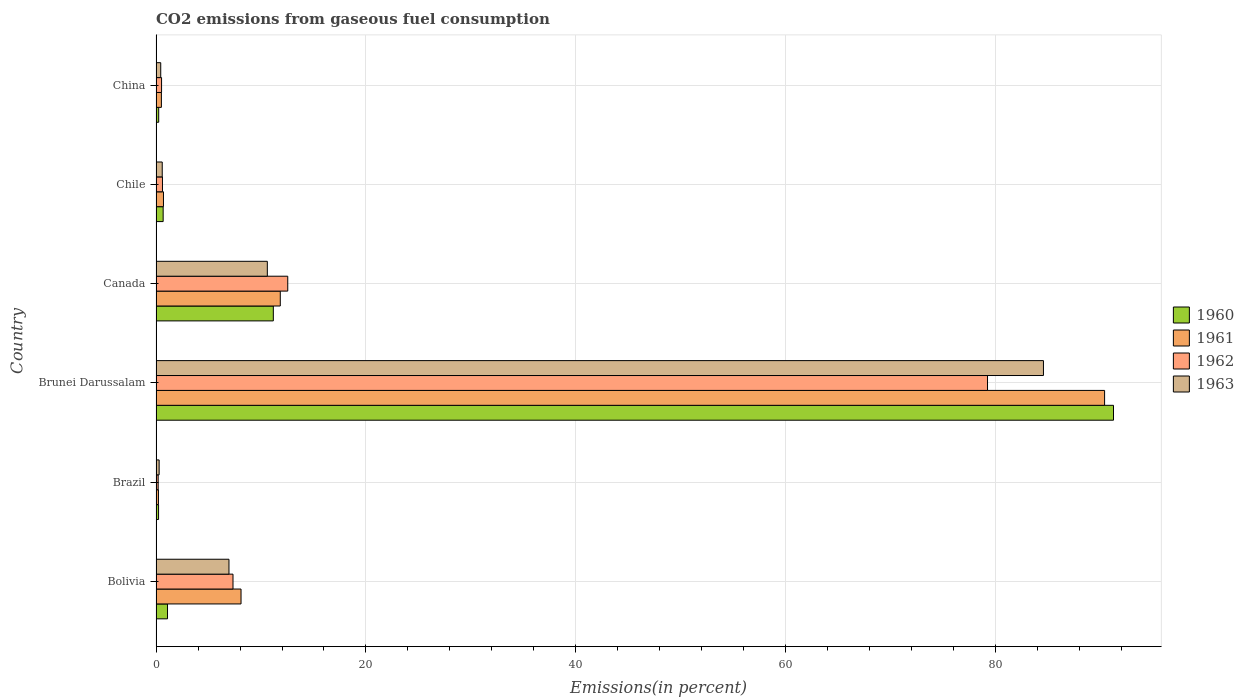How many groups of bars are there?
Ensure brevity in your answer.  6. How many bars are there on the 1st tick from the bottom?
Provide a succinct answer. 4. What is the total CO2 emitted in 1962 in Canada?
Your answer should be very brief. 12.55. Across all countries, what is the maximum total CO2 emitted in 1960?
Offer a very short reply. 91.21. Across all countries, what is the minimum total CO2 emitted in 1963?
Provide a short and direct response. 0.3. In which country was the total CO2 emitted in 1962 maximum?
Your answer should be compact. Brunei Darussalam. What is the total total CO2 emitted in 1960 in the graph?
Offer a very short reply. 104.66. What is the difference between the total CO2 emitted in 1961 in Brunei Darussalam and that in Chile?
Offer a very short reply. 89.65. What is the difference between the total CO2 emitted in 1962 in Brunei Darussalam and the total CO2 emitted in 1960 in Brazil?
Your response must be concise. 78.97. What is the average total CO2 emitted in 1963 per country?
Offer a very short reply. 17.24. What is the difference between the total CO2 emitted in 1963 and total CO2 emitted in 1962 in Chile?
Your answer should be very brief. -0.02. In how many countries, is the total CO2 emitted in 1960 greater than 60 %?
Ensure brevity in your answer.  1. What is the ratio of the total CO2 emitted in 1962 in Bolivia to that in China?
Offer a very short reply. 13.89. What is the difference between the highest and the second highest total CO2 emitted in 1961?
Offer a very short reply. 78.52. What is the difference between the highest and the lowest total CO2 emitted in 1960?
Provide a succinct answer. 90.97. Is it the case that in every country, the sum of the total CO2 emitted in 1962 and total CO2 emitted in 1961 is greater than the sum of total CO2 emitted in 1963 and total CO2 emitted in 1960?
Offer a terse response. No. What does the 2nd bar from the top in Canada represents?
Your answer should be compact. 1962. Is it the case that in every country, the sum of the total CO2 emitted in 1960 and total CO2 emitted in 1962 is greater than the total CO2 emitted in 1961?
Provide a succinct answer. Yes. How many bars are there?
Keep it short and to the point. 24. Are all the bars in the graph horizontal?
Give a very brief answer. Yes. How many countries are there in the graph?
Make the answer very short. 6. What is the difference between two consecutive major ticks on the X-axis?
Your response must be concise. 20. How are the legend labels stacked?
Give a very brief answer. Vertical. What is the title of the graph?
Ensure brevity in your answer.  CO2 emissions from gaseous fuel consumption. Does "1960" appear as one of the legend labels in the graph?
Your response must be concise. Yes. What is the label or title of the X-axis?
Keep it short and to the point. Emissions(in percent). What is the label or title of the Y-axis?
Your answer should be compact. Country. What is the Emissions(in percent) of 1960 in Bolivia?
Keep it short and to the point. 1.09. What is the Emissions(in percent) of 1961 in Bolivia?
Provide a succinct answer. 8.1. What is the Emissions(in percent) in 1962 in Bolivia?
Keep it short and to the point. 7.33. What is the Emissions(in percent) in 1963 in Bolivia?
Give a very brief answer. 6.95. What is the Emissions(in percent) of 1960 in Brazil?
Offer a very short reply. 0.24. What is the Emissions(in percent) in 1961 in Brazil?
Give a very brief answer. 0.23. What is the Emissions(in percent) in 1962 in Brazil?
Provide a short and direct response. 0.2. What is the Emissions(in percent) of 1963 in Brazil?
Your answer should be compact. 0.3. What is the Emissions(in percent) of 1960 in Brunei Darussalam?
Make the answer very short. 91.21. What is the Emissions(in percent) of 1961 in Brunei Darussalam?
Make the answer very short. 90.36. What is the Emissions(in percent) of 1962 in Brunei Darussalam?
Make the answer very short. 79.21. What is the Emissions(in percent) of 1963 in Brunei Darussalam?
Provide a succinct answer. 84.54. What is the Emissions(in percent) of 1960 in Canada?
Offer a terse response. 11.17. What is the Emissions(in percent) of 1961 in Canada?
Make the answer very short. 11.84. What is the Emissions(in percent) of 1962 in Canada?
Offer a very short reply. 12.55. What is the Emissions(in percent) in 1963 in Canada?
Offer a very short reply. 10.6. What is the Emissions(in percent) in 1960 in Chile?
Your answer should be very brief. 0.68. What is the Emissions(in percent) of 1961 in Chile?
Your answer should be compact. 0.71. What is the Emissions(in percent) in 1962 in Chile?
Offer a very short reply. 0.61. What is the Emissions(in percent) of 1963 in Chile?
Make the answer very short. 0.59. What is the Emissions(in percent) of 1960 in China?
Give a very brief answer. 0.26. What is the Emissions(in percent) of 1961 in China?
Your answer should be very brief. 0.51. What is the Emissions(in percent) of 1962 in China?
Your response must be concise. 0.53. What is the Emissions(in percent) in 1963 in China?
Give a very brief answer. 0.45. Across all countries, what is the maximum Emissions(in percent) of 1960?
Your response must be concise. 91.21. Across all countries, what is the maximum Emissions(in percent) of 1961?
Make the answer very short. 90.36. Across all countries, what is the maximum Emissions(in percent) in 1962?
Provide a short and direct response. 79.21. Across all countries, what is the maximum Emissions(in percent) in 1963?
Keep it short and to the point. 84.54. Across all countries, what is the minimum Emissions(in percent) in 1960?
Offer a very short reply. 0.24. Across all countries, what is the minimum Emissions(in percent) of 1961?
Offer a terse response. 0.23. Across all countries, what is the minimum Emissions(in percent) in 1962?
Your answer should be very brief. 0.2. Across all countries, what is the minimum Emissions(in percent) of 1963?
Offer a very short reply. 0.3. What is the total Emissions(in percent) in 1960 in the graph?
Your answer should be very brief. 104.66. What is the total Emissions(in percent) of 1961 in the graph?
Keep it short and to the point. 111.75. What is the total Emissions(in percent) in 1962 in the graph?
Make the answer very short. 100.44. What is the total Emissions(in percent) of 1963 in the graph?
Your response must be concise. 103.42. What is the difference between the Emissions(in percent) of 1960 in Bolivia and that in Brazil?
Your response must be concise. 0.85. What is the difference between the Emissions(in percent) in 1961 in Bolivia and that in Brazil?
Ensure brevity in your answer.  7.87. What is the difference between the Emissions(in percent) in 1962 in Bolivia and that in Brazil?
Your answer should be compact. 7.13. What is the difference between the Emissions(in percent) of 1963 in Bolivia and that in Brazil?
Make the answer very short. 6.65. What is the difference between the Emissions(in percent) of 1960 in Bolivia and that in Brunei Darussalam?
Offer a terse response. -90.11. What is the difference between the Emissions(in percent) in 1961 in Bolivia and that in Brunei Darussalam?
Your response must be concise. -82.26. What is the difference between the Emissions(in percent) of 1962 in Bolivia and that in Brunei Darussalam?
Your answer should be very brief. -71.87. What is the difference between the Emissions(in percent) of 1963 in Bolivia and that in Brunei Darussalam?
Offer a terse response. -77.59. What is the difference between the Emissions(in percent) in 1960 in Bolivia and that in Canada?
Offer a terse response. -10.08. What is the difference between the Emissions(in percent) in 1961 in Bolivia and that in Canada?
Offer a very short reply. -3.74. What is the difference between the Emissions(in percent) of 1962 in Bolivia and that in Canada?
Give a very brief answer. -5.22. What is the difference between the Emissions(in percent) in 1963 in Bolivia and that in Canada?
Ensure brevity in your answer.  -3.65. What is the difference between the Emissions(in percent) in 1960 in Bolivia and that in Chile?
Make the answer very short. 0.42. What is the difference between the Emissions(in percent) of 1961 in Bolivia and that in Chile?
Provide a short and direct response. 7.39. What is the difference between the Emissions(in percent) in 1962 in Bolivia and that in Chile?
Offer a terse response. 6.72. What is the difference between the Emissions(in percent) in 1963 in Bolivia and that in Chile?
Your answer should be very brief. 6.36. What is the difference between the Emissions(in percent) in 1960 in Bolivia and that in China?
Provide a succinct answer. 0.84. What is the difference between the Emissions(in percent) of 1961 in Bolivia and that in China?
Ensure brevity in your answer.  7.59. What is the difference between the Emissions(in percent) of 1962 in Bolivia and that in China?
Your answer should be compact. 6.81. What is the difference between the Emissions(in percent) in 1963 in Bolivia and that in China?
Your answer should be compact. 6.5. What is the difference between the Emissions(in percent) of 1960 in Brazil and that in Brunei Darussalam?
Offer a terse response. -90.97. What is the difference between the Emissions(in percent) in 1961 in Brazil and that in Brunei Darussalam?
Your answer should be compact. -90.13. What is the difference between the Emissions(in percent) in 1962 in Brazil and that in Brunei Darussalam?
Provide a succinct answer. -79. What is the difference between the Emissions(in percent) of 1963 in Brazil and that in Brunei Darussalam?
Offer a terse response. -84.24. What is the difference between the Emissions(in percent) in 1960 in Brazil and that in Canada?
Give a very brief answer. -10.93. What is the difference between the Emissions(in percent) of 1961 in Brazil and that in Canada?
Your answer should be compact. -11.61. What is the difference between the Emissions(in percent) of 1962 in Brazil and that in Canada?
Offer a terse response. -12.34. What is the difference between the Emissions(in percent) of 1963 in Brazil and that in Canada?
Provide a short and direct response. -10.31. What is the difference between the Emissions(in percent) in 1960 in Brazil and that in Chile?
Your response must be concise. -0.44. What is the difference between the Emissions(in percent) in 1961 in Brazil and that in Chile?
Offer a terse response. -0.48. What is the difference between the Emissions(in percent) of 1962 in Brazil and that in Chile?
Your answer should be compact. -0.41. What is the difference between the Emissions(in percent) of 1963 in Brazil and that in Chile?
Keep it short and to the point. -0.29. What is the difference between the Emissions(in percent) in 1960 in Brazil and that in China?
Offer a terse response. -0.01. What is the difference between the Emissions(in percent) of 1961 in Brazil and that in China?
Offer a very short reply. -0.28. What is the difference between the Emissions(in percent) of 1962 in Brazil and that in China?
Keep it short and to the point. -0.32. What is the difference between the Emissions(in percent) in 1963 in Brazil and that in China?
Keep it short and to the point. -0.15. What is the difference between the Emissions(in percent) of 1960 in Brunei Darussalam and that in Canada?
Your response must be concise. 80.03. What is the difference between the Emissions(in percent) of 1961 in Brunei Darussalam and that in Canada?
Give a very brief answer. 78.52. What is the difference between the Emissions(in percent) in 1962 in Brunei Darussalam and that in Canada?
Give a very brief answer. 66.66. What is the difference between the Emissions(in percent) of 1963 in Brunei Darussalam and that in Canada?
Provide a succinct answer. 73.93. What is the difference between the Emissions(in percent) of 1960 in Brunei Darussalam and that in Chile?
Ensure brevity in your answer.  90.53. What is the difference between the Emissions(in percent) in 1961 in Brunei Darussalam and that in Chile?
Provide a succinct answer. 89.65. What is the difference between the Emissions(in percent) in 1962 in Brunei Darussalam and that in Chile?
Give a very brief answer. 78.59. What is the difference between the Emissions(in percent) in 1963 in Brunei Darussalam and that in Chile?
Give a very brief answer. 83.94. What is the difference between the Emissions(in percent) of 1960 in Brunei Darussalam and that in China?
Keep it short and to the point. 90.95. What is the difference between the Emissions(in percent) in 1961 in Brunei Darussalam and that in China?
Provide a succinct answer. 89.85. What is the difference between the Emissions(in percent) of 1962 in Brunei Darussalam and that in China?
Your answer should be compact. 78.68. What is the difference between the Emissions(in percent) in 1963 in Brunei Darussalam and that in China?
Ensure brevity in your answer.  84.09. What is the difference between the Emissions(in percent) of 1960 in Canada and that in Chile?
Your answer should be compact. 10.49. What is the difference between the Emissions(in percent) of 1961 in Canada and that in Chile?
Make the answer very short. 11.13. What is the difference between the Emissions(in percent) in 1962 in Canada and that in Chile?
Make the answer very short. 11.93. What is the difference between the Emissions(in percent) in 1963 in Canada and that in Chile?
Keep it short and to the point. 10.01. What is the difference between the Emissions(in percent) of 1960 in Canada and that in China?
Provide a short and direct response. 10.92. What is the difference between the Emissions(in percent) in 1961 in Canada and that in China?
Provide a succinct answer. 11.33. What is the difference between the Emissions(in percent) of 1962 in Canada and that in China?
Make the answer very short. 12.02. What is the difference between the Emissions(in percent) of 1963 in Canada and that in China?
Offer a terse response. 10.15. What is the difference between the Emissions(in percent) in 1960 in Chile and that in China?
Offer a terse response. 0.42. What is the difference between the Emissions(in percent) of 1961 in Chile and that in China?
Ensure brevity in your answer.  0.2. What is the difference between the Emissions(in percent) of 1962 in Chile and that in China?
Keep it short and to the point. 0.09. What is the difference between the Emissions(in percent) of 1963 in Chile and that in China?
Your answer should be compact. 0.14. What is the difference between the Emissions(in percent) of 1960 in Bolivia and the Emissions(in percent) of 1961 in Brazil?
Your answer should be very brief. 0.86. What is the difference between the Emissions(in percent) of 1960 in Bolivia and the Emissions(in percent) of 1962 in Brazil?
Provide a short and direct response. 0.89. What is the difference between the Emissions(in percent) of 1960 in Bolivia and the Emissions(in percent) of 1963 in Brazil?
Your response must be concise. 0.8. What is the difference between the Emissions(in percent) of 1961 in Bolivia and the Emissions(in percent) of 1962 in Brazil?
Ensure brevity in your answer.  7.89. What is the difference between the Emissions(in percent) in 1961 in Bolivia and the Emissions(in percent) in 1963 in Brazil?
Provide a short and direct response. 7.8. What is the difference between the Emissions(in percent) in 1962 in Bolivia and the Emissions(in percent) in 1963 in Brazil?
Give a very brief answer. 7.04. What is the difference between the Emissions(in percent) of 1960 in Bolivia and the Emissions(in percent) of 1961 in Brunei Darussalam?
Ensure brevity in your answer.  -89.27. What is the difference between the Emissions(in percent) in 1960 in Bolivia and the Emissions(in percent) in 1962 in Brunei Darussalam?
Make the answer very short. -78.11. What is the difference between the Emissions(in percent) of 1960 in Bolivia and the Emissions(in percent) of 1963 in Brunei Darussalam?
Give a very brief answer. -83.44. What is the difference between the Emissions(in percent) of 1961 in Bolivia and the Emissions(in percent) of 1962 in Brunei Darussalam?
Your answer should be very brief. -71.11. What is the difference between the Emissions(in percent) of 1961 in Bolivia and the Emissions(in percent) of 1963 in Brunei Darussalam?
Keep it short and to the point. -76.44. What is the difference between the Emissions(in percent) of 1962 in Bolivia and the Emissions(in percent) of 1963 in Brunei Darussalam?
Provide a short and direct response. -77.2. What is the difference between the Emissions(in percent) of 1960 in Bolivia and the Emissions(in percent) of 1961 in Canada?
Keep it short and to the point. -10.74. What is the difference between the Emissions(in percent) of 1960 in Bolivia and the Emissions(in percent) of 1962 in Canada?
Provide a succinct answer. -11.45. What is the difference between the Emissions(in percent) of 1960 in Bolivia and the Emissions(in percent) of 1963 in Canada?
Your response must be concise. -9.51. What is the difference between the Emissions(in percent) of 1961 in Bolivia and the Emissions(in percent) of 1962 in Canada?
Ensure brevity in your answer.  -4.45. What is the difference between the Emissions(in percent) of 1961 in Bolivia and the Emissions(in percent) of 1963 in Canada?
Make the answer very short. -2.5. What is the difference between the Emissions(in percent) of 1962 in Bolivia and the Emissions(in percent) of 1963 in Canada?
Provide a short and direct response. -3.27. What is the difference between the Emissions(in percent) in 1960 in Bolivia and the Emissions(in percent) in 1961 in Chile?
Your answer should be compact. 0.39. What is the difference between the Emissions(in percent) in 1960 in Bolivia and the Emissions(in percent) in 1962 in Chile?
Offer a very short reply. 0.48. What is the difference between the Emissions(in percent) in 1960 in Bolivia and the Emissions(in percent) in 1963 in Chile?
Provide a succinct answer. 0.5. What is the difference between the Emissions(in percent) of 1961 in Bolivia and the Emissions(in percent) of 1962 in Chile?
Your answer should be compact. 7.48. What is the difference between the Emissions(in percent) of 1961 in Bolivia and the Emissions(in percent) of 1963 in Chile?
Keep it short and to the point. 7.51. What is the difference between the Emissions(in percent) in 1962 in Bolivia and the Emissions(in percent) in 1963 in Chile?
Your answer should be compact. 6.74. What is the difference between the Emissions(in percent) of 1960 in Bolivia and the Emissions(in percent) of 1961 in China?
Keep it short and to the point. 0.58. What is the difference between the Emissions(in percent) of 1960 in Bolivia and the Emissions(in percent) of 1962 in China?
Make the answer very short. 0.57. What is the difference between the Emissions(in percent) of 1960 in Bolivia and the Emissions(in percent) of 1963 in China?
Provide a succinct answer. 0.65. What is the difference between the Emissions(in percent) of 1961 in Bolivia and the Emissions(in percent) of 1962 in China?
Your answer should be compact. 7.57. What is the difference between the Emissions(in percent) in 1961 in Bolivia and the Emissions(in percent) in 1963 in China?
Keep it short and to the point. 7.65. What is the difference between the Emissions(in percent) in 1962 in Bolivia and the Emissions(in percent) in 1963 in China?
Your response must be concise. 6.88. What is the difference between the Emissions(in percent) in 1960 in Brazil and the Emissions(in percent) in 1961 in Brunei Darussalam?
Make the answer very short. -90.12. What is the difference between the Emissions(in percent) of 1960 in Brazil and the Emissions(in percent) of 1962 in Brunei Darussalam?
Your answer should be compact. -78.97. What is the difference between the Emissions(in percent) of 1960 in Brazil and the Emissions(in percent) of 1963 in Brunei Darussalam?
Your answer should be very brief. -84.29. What is the difference between the Emissions(in percent) of 1961 in Brazil and the Emissions(in percent) of 1962 in Brunei Darussalam?
Give a very brief answer. -78.98. What is the difference between the Emissions(in percent) in 1961 in Brazil and the Emissions(in percent) in 1963 in Brunei Darussalam?
Provide a succinct answer. -84.31. What is the difference between the Emissions(in percent) in 1962 in Brazil and the Emissions(in percent) in 1963 in Brunei Darussalam?
Offer a terse response. -84.33. What is the difference between the Emissions(in percent) of 1960 in Brazil and the Emissions(in percent) of 1961 in Canada?
Offer a very short reply. -11.59. What is the difference between the Emissions(in percent) in 1960 in Brazil and the Emissions(in percent) in 1962 in Canada?
Keep it short and to the point. -12.31. What is the difference between the Emissions(in percent) in 1960 in Brazil and the Emissions(in percent) in 1963 in Canada?
Make the answer very short. -10.36. What is the difference between the Emissions(in percent) of 1961 in Brazil and the Emissions(in percent) of 1962 in Canada?
Give a very brief answer. -12.32. What is the difference between the Emissions(in percent) in 1961 in Brazil and the Emissions(in percent) in 1963 in Canada?
Offer a very short reply. -10.37. What is the difference between the Emissions(in percent) in 1962 in Brazil and the Emissions(in percent) in 1963 in Canada?
Provide a succinct answer. -10.4. What is the difference between the Emissions(in percent) of 1960 in Brazil and the Emissions(in percent) of 1961 in Chile?
Provide a succinct answer. -0.47. What is the difference between the Emissions(in percent) in 1960 in Brazil and the Emissions(in percent) in 1962 in Chile?
Provide a short and direct response. -0.37. What is the difference between the Emissions(in percent) of 1960 in Brazil and the Emissions(in percent) of 1963 in Chile?
Your response must be concise. -0.35. What is the difference between the Emissions(in percent) of 1961 in Brazil and the Emissions(in percent) of 1962 in Chile?
Make the answer very short. -0.38. What is the difference between the Emissions(in percent) in 1961 in Brazil and the Emissions(in percent) in 1963 in Chile?
Keep it short and to the point. -0.36. What is the difference between the Emissions(in percent) in 1962 in Brazil and the Emissions(in percent) in 1963 in Chile?
Provide a succinct answer. -0.39. What is the difference between the Emissions(in percent) in 1960 in Brazil and the Emissions(in percent) in 1961 in China?
Provide a succinct answer. -0.27. What is the difference between the Emissions(in percent) of 1960 in Brazil and the Emissions(in percent) of 1962 in China?
Your response must be concise. -0.29. What is the difference between the Emissions(in percent) in 1960 in Brazil and the Emissions(in percent) in 1963 in China?
Offer a terse response. -0.21. What is the difference between the Emissions(in percent) in 1961 in Brazil and the Emissions(in percent) in 1962 in China?
Offer a very short reply. -0.3. What is the difference between the Emissions(in percent) in 1961 in Brazil and the Emissions(in percent) in 1963 in China?
Provide a succinct answer. -0.22. What is the difference between the Emissions(in percent) of 1962 in Brazil and the Emissions(in percent) of 1963 in China?
Provide a succinct answer. -0.24. What is the difference between the Emissions(in percent) of 1960 in Brunei Darussalam and the Emissions(in percent) of 1961 in Canada?
Your answer should be very brief. 79.37. What is the difference between the Emissions(in percent) in 1960 in Brunei Darussalam and the Emissions(in percent) in 1962 in Canada?
Make the answer very short. 78.66. What is the difference between the Emissions(in percent) in 1960 in Brunei Darussalam and the Emissions(in percent) in 1963 in Canada?
Give a very brief answer. 80.61. What is the difference between the Emissions(in percent) in 1961 in Brunei Darussalam and the Emissions(in percent) in 1962 in Canada?
Your response must be concise. 77.81. What is the difference between the Emissions(in percent) in 1961 in Brunei Darussalam and the Emissions(in percent) in 1963 in Canada?
Make the answer very short. 79.76. What is the difference between the Emissions(in percent) in 1962 in Brunei Darussalam and the Emissions(in percent) in 1963 in Canada?
Your response must be concise. 68.61. What is the difference between the Emissions(in percent) of 1960 in Brunei Darussalam and the Emissions(in percent) of 1961 in Chile?
Your answer should be very brief. 90.5. What is the difference between the Emissions(in percent) in 1960 in Brunei Darussalam and the Emissions(in percent) in 1962 in Chile?
Your response must be concise. 90.59. What is the difference between the Emissions(in percent) of 1960 in Brunei Darussalam and the Emissions(in percent) of 1963 in Chile?
Give a very brief answer. 90.62. What is the difference between the Emissions(in percent) of 1961 in Brunei Darussalam and the Emissions(in percent) of 1962 in Chile?
Make the answer very short. 89.75. What is the difference between the Emissions(in percent) in 1961 in Brunei Darussalam and the Emissions(in percent) in 1963 in Chile?
Ensure brevity in your answer.  89.77. What is the difference between the Emissions(in percent) of 1962 in Brunei Darussalam and the Emissions(in percent) of 1963 in Chile?
Give a very brief answer. 78.62. What is the difference between the Emissions(in percent) in 1960 in Brunei Darussalam and the Emissions(in percent) in 1961 in China?
Give a very brief answer. 90.7. What is the difference between the Emissions(in percent) in 1960 in Brunei Darussalam and the Emissions(in percent) in 1962 in China?
Make the answer very short. 90.68. What is the difference between the Emissions(in percent) in 1960 in Brunei Darussalam and the Emissions(in percent) in 1963 in China?
Give a very brief answer. 90.76. What is the difference between the Emissions(in percent) of 1961 in Brunei Darussalam and the Emissions(in percent) of 1962 in China?
Make the answer very short. 89.83. What is the difference between the Emissions(in percent) in 1961 in Brunei Darussalam and the Emissions(in percent) in 1963 in China?
Provide a short and direct response. 89.91. What is the difference between the Emissions(in percent) in 1962 in Brunei Darussalam and the Emissions(in percent) in 1963 in China?
Your answer should be compact. 78.76. What is the difference between the Emissions(in percent) of 1960 in Canada and the Emissions(in percent) of 1961 in Chile?
Your response must be concise. 10.46. What is the difference between the Emissions(in percent) in 1960 in Canada and the Emissions(in percent) in 1962 in Chile?
Provide a short and direct response. 10.56. What is the difference between the Emissions(in percent) in 1960 in Canada and the Emissions(in percent) in 1963 in Chile?
Ensure brevity in your answer.  10.58. What is the difference between the Emissions(in percent) of 1961 in Canada and the Emissions(in percent) of 1962 in Chile?
Keep it short and to the point. 11.22. What is the difference between the Emissions(in percent) in 1961 in Canada and the Emissions(in percent) in 1963 in Chile?
Give a very brief answer. 11.25. What is the difference between the Emissions(in percent) of 1962 in Canada and the Emissions(in percent) of 1963 in Chile?
Your answer should be very brief. 11.96. What is the difference between the Emissions(in percent) in 1960 in Canada and the Emissions(in percent) in 1961 in China?
Offer a terse response. 10.66. What is the difference between the Emissions(in percent) in 1960 in Canada and the Emissions(in percent) in 1962 in China?
Ensure brevity in your answer.  10.65. What is the difference between the Emissions(in percent) of 1960 in Canada and the Emissions(in percent) of 1963 in China?
Keep it short and to the point. 10.73. What is the difference between the Emissions(in percent) of 1961 in Canada and the Emissions(in percent) of 1962 in China?
Your answer should be very brief. 11.31. What is the difference between the Emissions(in percent) of 1961 in Canada and the Emissions(in percent) of 1963 in China?
Give a very brief answer. 11.39. What is the difference between the Emissions(in percent) of 1962 in Canada and the Emissions(in percent) of 1963 in China?
Your answer should be compact. 12.1. What is the difference between the Emissions(in percent) in 1960 in Chile and the Emissions(in percent) in 1961 in China?
Keep it short and to the point. 0.17. What is the difference between the Emissions(in percent) in 1960 in Chile and the Emissions(in percent) in 1962 in China?
Provide a succinct answer. 0.15. What is the difference between the Emissions(in percent) in 1960 in Chile and the Emissions(in percent) in 1963 in China?
Provide a short and direct response. 0.23. What is the difference between the Emissions(in percent) of 1961 in Chile and the Emissions(in percent) of 1962 in China?
Ensure brevity in your answer.  0.18. What is the difference between the Emissions(in percent) of 1961 in Chile and the Emissions(in percent) of 1963 in China?
Make the answer very short. 0.26. What is the difference between the Emissions(in percent) in 1962 in Chile and the Emissions(in percent) in 1963 in China?
Offer a terse response. 0.17. What is the average Emissions(in percent) of 1960 per country?
Your answer should be compact. 17.44. What is the average Emissions(in percent) of 1961 per country?
Your answer should be very brief. 18.62. What is the average Emissions(in percent) of 1962 per country?
Ensure brevity in your answer.  16.74. What is the average Emissions(in percent) in 1963 per country?
Offer a terse response. 17.24. What is the difference between the Emissions(in percent) of 1960 and Emissions(in percent) of 1961 in Bolivia?
Your answer should be very brief. -7. What is the difference between the Emissions(in percent) in 1960 and Emissions(in percent) in 1962 in Bolivia?
Provide a short and direct response. -6.24. What is the difference between the Emissions(in percent) of 1960 and Emissions(in percent) of 1963 in Bolivia?
Your answer should be very brief. -5.85. What is the difference between the Emissions(in percent) in 1961 and Emissions(in percent) in 1962 in Bolivia?
Your answer should be very brief. 0.77. What is the difference between the Emissions(in percent) in 1961 and Emissions(in percent) in 1963 in Bolivia?
Your answer should be compact. 1.15. What is the difference between the Emissions(in percent) in 1962 and Emissions(in percent) in 1963 in Bolivia?
Keep it short and to the point. 0.38. What is the difference between the Emissions(in percent) of 1960 and Emissions(in percent) of 1961 in Brazil?
Give a very brief answer. 0.01. What is the difference between the Emissions(in percent) in 1960 and Emissions(in percent) in 1962 in Brazil?
Ensure brevity in your answer.  0.04. What is the difference between the Emissions(in percent) of 1960 and Emissions(in percent) of 1963 in Brazil?
Make the answer very short. -0.05. What is the difference between the Emissions(in percent) in 1961 and Emissions(in percent) in 1962 in Brazil?
Give a very brief answer. 0.03. What is the difference between the Emissions(in percent) of 1961 and Emissions(in percent) of 1963 in Brazil?
Make the answer very short. -0.07. What is the difference between the Emissions(in percent) in 1962 and Emissions(in percent) in 1963 in Brazil?
Keep it short and to the point. -0.09. What is the difference between the Emissions(in percent) of 1960 and Emissions(in percent) of 1961 in Brunei Darussalam?
Keep it short and to the point. 0.85. What is the difference between the Emissions(in percent) in 1960 and Emissions(in percent) in 1962 in Brunei Darussalam?
Ensure brevity in your answer.  12. What is the difference between the Emissions(in percent) in 1960 and Emissions(in percent) in 1963 in Brunei Darussalam?
Offer a terse response. 6.67. What is the difference between the Emissions(in percent) in 1961 and Emissions(in percent) in 1962 in Brunei Darussalam?
Provide a short and direct response. 11.15. What is the difference between the Emissions(in percent) in 1961 and Emissions(in percent) in 1963 in Brunei Darussalam?
Make the answer very short. 5.83. What is the difference between the Emissions(in percent) of 1962 and Emissions(in percent) of 1963 in Brunei Darussalam?
Keep it short and to the point. -5.33. What is the difference between the Emissions(in percent) in 1960 and Emissions(in percent) in 1961 in Canada?
Your response must be concise. -0.66. What is the difference between the Emissions(in percent) of 1960 and Emissions(in percent) of 1962 in Canada?
Give a very brief answer. -1.37. What is the difference between the Emissions(in percent) of 1960 and Emissions(in percent) of 1963 in Canada?
Give a very brief answer. 0.57. What is the difference between the Emissions(in percent) of 1961 and Emissions(in percent) of 1962 in Canada?
Keep it short and to the point. -0.71. What is the difference between the Emissions(in percent) in 1961 and Emissions(in percent) in 1963 in Canada?
Make the answer very short. 1.23. What is the difference between the Emissions(in percent) in 1962 and Emissions(in percent) in 1963 in Canada?
Your response must be concise. 1.95. What is the difference between the Emissions(in percent) of 1960 and Emissions(in percent) of 1961 in Chile?
Provide a short and direct response. -0.03. What is the difference between the Emissions(in percent) in 1960 and Emissions(in percent) in 1962 in Chile?
Your response must be concise. 0.07. What is the difference between the Emissions(in percent) in 1960 and Emissions(in percent) in 1963 in Chile?
Offer a terse response. 0.09. What is the difference between the Emissions(in percent) of 1961 and Emissions(in percent) of 1962 in Chile?
Give a very brief answer. 0.1. What is the difference between the Emissions(in percent) of 1961 and Emissions(in percent) of 1963 in Chile?
Provide a succinct answer. 0.12. What is the difference between the Emissions(in percent) of 1962 and Emissions(in percent) of 1963 in Chile?
Your answer should be compact. 0.02. What is the difference between the Emissions(in percent) of 1960 and Emissions(in percent) of 1961 in China?
Ensure brevity in your answer.  -0.26. What is the difference between the Emissions(in percent) of 1960 and Emissions(in percent) of 1962 in China?
Your response must be concise. -0.27. What is the difference between the Emissions(in percent) in 1960 and Emissions(in percent) in 1963 in China?
Ensure brevity in your answer.  -0.19. What is the difference between the Emissions(in percent) in 1961 and Emissions(in percent) in 1962 in China?
Offer a very short reply. -0.02. What is the difference between the Emissions(in percent) in 1961 and Emissions(in percent) in 1963 in China?
Provide a short and direct response. 0.06. What is the difference between the Emissions(in percent) in 1962 and Emissions(in percent) in 1963 in China?
Make the answer very short. 0.08. What is the ratio of the Emissions(in percent) of 1960 in Bolivia to that in Brazil?
Your answer should be very brief. 4.52. What is the ratio of the Emissions(in percent) in 1961 in Bolivia to that in Brazil?
Provide a short and direct response. 35.05. What is the ratio of the Emissions(in percent) in 1962 in Bolivia to that in Brazil?
Offer a very short reply. 35.79. What is the ratio of the Emissions(in percent) in 1963 in Bolivia to that in Brazil?
Your answer should be very brief. 23.42. What is the ratio of the Emissions(in percent) of 1960 in Bolivia to that in Brunei Darussalam?
Make the answer very short. 0.01. What is the ratio of the Emissions(in percent) of 1961 in Bolivia to that in Brunei Darussalam?
Your answer should be very brief. 0.09. What is the ratio of the Emissions(in percent) of 1962 in Bolivia to that in Brunei Darussalam?
Your answer should be compact. 0.09. What is the ratio of the Emissions(in percent) of 1963 in Bolivia to that in Brunei Darussalam?
Offer a terse response. 0.08. What is the ratio of the Emissions(in percent) of 1960 in Bolivia to that in Canada?
Offer a terse response. 0.1. What is the ratio of the Emissions(in percent) in 1961 in Bolivia to that in Canada?
Keep it short and to the point. 0.68. What is the ratio of the Emissions(in percent) of 1962 in Bolivia to that in Canada?
Give a very brief answer. 0.58. What is the ratio of the Emissions(in percent) of 1963 in Bolivia to that in Canada?
Your response must be concise. 0.66. What is the ratio of the Emissions(in percent) of 1960 in Bolivia to that in Chile?
Ensure brevity in your answer.  1.61. What is the ratio of the Emissions(in percent) of 1961 in Bolivia to that in Chile?
Your answer should be compact. 11.42. What is the ratio of the Emissions(in percent) of 1962 in Bolivia to that in Chile?
Provide a succinct answer. 11.95. What is the ratio of the Emissions(in percent) in 1963 in Bolivia to that in Chile?
Your answer should be very brief. 11.75. What is the ratio of the Emissions(in percent) in 1960 in Bolivia to that in China?
Keep it short and to the point. 4.29. What is the ratio of the Emissions(in percent) of 1961 in Bolivia to that in China?
Provide a succinct answer. 15.85. What is the ratio of the Emissions(in percent) of 1962 in Bolivia to that in China?
Your answer should be compact. 13.89. What is the ratio of the Emissions(in percent) of 1963 in Bolivia to that in China?
Offer a very short reply. 15.5. What is the ratio of the Emissions(in percent) in 1960 in Brazil to that in Brunei Darussalam?
Keep it short and to the point. 0. What is the ratio of the Emissions(in percent) of 1961 in Brazil to that in Brunei Darussalam?
Give a very brief answer. 0. What is the ratio of the Emissions(in percent) of 1962 in Brazil to that in Brunei Darussalam?
Your answer should be compact. 0. What is the ratio of the Emissions(in percent) of 1963 in Brazil to that in Brunei Darussalam?
Your answer should be compact. 0. What is the ratio of the Emissions(in percent) in 1960 in Brazil to that in Canada?
Make the answer very short. 0.02. What is the ratio of the Emissions(in percent) of 1961 in Brazil to that in Canada?
Provide a short and direct response. 0.02. What is the ratio of the Emissions(in percent) in 1962 in Brazil to that in Canada?
Your answer should be very brief. 0.02. What is the ratio of the Emissions(in percent) of 1963 in Brazil to that in Canada?
Your answer should be very brief. 0.03. What is the ratio of the Emissions(in percent) of 1960 in Brazil to that in Chile?
Your answer should be very brief. 0.36. What is the ratio of the Emissions(in percent) in 1961 in Brazil to that in Chile?
Your answer should be very brief. 0.33. What is the ratio of the Emissions(in percent) in 1962 in Brazil to that in Chile?
Give a very brief answer. 0.33. What is the ratio of the Emissions(in percent) in 1963 in Brazil to that in Chile?
Ensure brevity in your answer.  0.5. What is the ratio of the Emissions(in percent) in 1960 in Brazil to that in China?
Provide a succinct answer. 0.95. What is the ratio of the Emissions(in percent) in 1961 in Brazil to that in China?
Make the answer very short. 0.45. What is the ratio of the Emissions(in percent) of 1962 in Brazil to that in China?
Provide a succinct answer. 0.39. What is the ratio of the Emissions(in percent) of 1963 in Brazil to that in China?
Ensure brevity in your answer.  0.66. What is the ratio of the Emissions(in percent) of 1960 in Brunei Darussalam to that in Canada?
Offer a terse response. 8.16. What is the ratio of the Emissions(in percent) in 1961 in Brunei Darussalam to that in Canada?
Offer a very short reply. 7.63. What is the ratio of the Emissions(in percent) in 1962 in Brunei Darussalam to that in Canada?
Provide a succinct answer. 6.31. What is the ratio of the Emissions(in percent) of 1963 in Brunei Darussalam to that in Canada?
Provide a short and direct response. 7.97. What is the ratio of the Emissions(in percent) in 1960 in Brunei Darussalam to that in Chile?
Offer a terse response. 134.22. What is the ratio of the Emissions(in percent) of 1961 in Brunei Darussalam to that in Chile?
Your answer should be compact. 127.38. What is the ratio of the Emissions(in percent) in 1962 in Brunei Darussalam to that in Chile?
Offer a terse response. 129.02. What is the ratio of the Emissions(in percent) in 1963 in Brunei Darussalam to that in Chile?
Provide a succinct answer. 142.9. What is the ratio of the Emissions(in percent) of 1960 in Brunei Darussalam to that in China?
Your answer should be very brief. 356.97. What is the ratio of the Emissions(in percent) of 1961 in Brunei Darussalam to that in China?
Keep it short and to the point. 176.9. What is the ratio of the Emissions(in percent) in 1962 in Brunei Darussalam to that in China?
Keep it short and to the point. 150.03. What is the ratio of the Emissions(in percent) of 1963 in Brunei Darussalam to that in China?
Your answer should be very brief. 188.53. What is the ratio of the Emissions(in percent) of 1960 in Canada to that in Chile?
Your answer should be very brief. 16.44. What is the ratio of the Emissions(in percent) of 1961 in Canada to that in Chile?
Make the answer very short. 16.69. What is the ratio of the Emissions(in percent) in 1962 in Canada to that in Chile?
Offer a very short reply. 20.44. What is the ratio of the Emissions(in percent) in 1963 in Canada to that in Chile?
Provide a succinct answer. 17.92. What is the ratio of the Emissions(in percent) in 1960 in Canada to that in China?
Keep it short and to the point. 43.73. What is the ratio of the Emissions(in percent) in 1961 in Canada to that in China?
Offer a very short reply. 23.17. What is the ratio of the Emissions(in percent) in 1962 in Canada to that in China?
Offer a very short reply. 23.77. What is the ratio of the Emissions(in percent) of 1963 in Canada to that in China?
Keep it short and to the point. 23.65. What is the ratio of the Emissions(in percent) in 1960 in Chile to that in China?
Give a very brief answer. 2.66. What is the ratio of the Emissions(in percent) in 1961 in Chile to that in China?
Ensure brevity in your answer.  1.39. What is the ratio of the Emissions(in percent) in 1962 in Chile to that in China?
Offer a terse response. 1.16. What is the ratio of the Emissions(in percent) in 1963 in Chile to that in China?
Ensure brevity in your answer.  1.32. What is the difference between the highest and the second highest Emissions(in percent) of 1960?
Offer a terse response. 80.03. What is the difference between the highest and the second highest Emissions(in percent) in 1961?
Give a very brief answer. 78.52. What is the difference between the highest and the second highest Emissions(in percent) of 1962?
Offer a very short reply. 66.66. What is the difference between the highest and the second highest Emissions(in percent) in 1963?
Make the answer very short. 73.93. What is the difference between the highest and the lowest Emissions(in percent) of 1960?
Your answer should be compact. 90.97. What is the difference between the highest and the lowest Emissions(in percent) in 1961?
Keep it short and to the point. 90.13. What is the difference between the highest and the lowest Emissions(in percent) in 1962?
Offer a very short reply. 79. What is the difference between the highest and the lowest Emissions(in percent) in 1963?
Give a very brief answer. 84.24. 